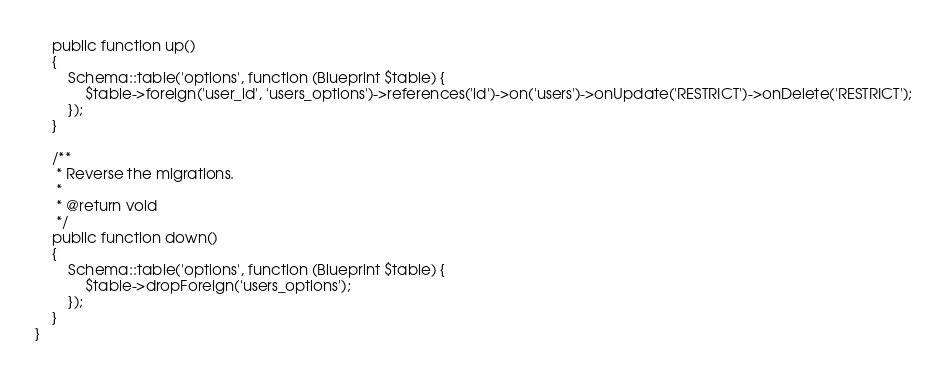<code> <loc_0><loc_0><loc_500><loc_500><_PHP_>    public function up()
    {
        Schema::table('options', function (Blueprint $table) {
            $table->foreign('user_id', 'users_options')->references('id')->on('users')->onUpdate('RESTRICT')->onDelete('RESTRICT');
        });
    }

    /**
     * Reverse the migrations.
     *
     * @return void
     */
    public function down()
    {
        Schema::table('options', function (Blueprint $table) {
            $table->dropForeign('users_options');
        });
    }
}
</code> 